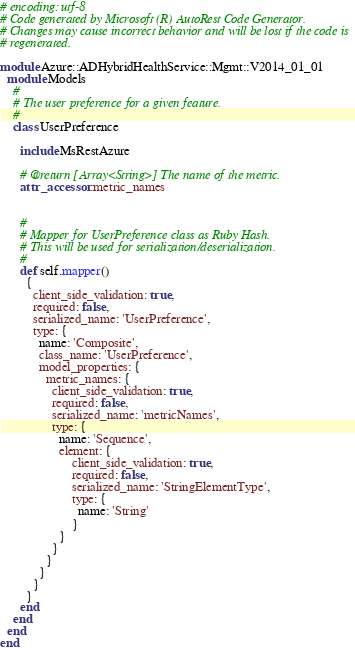Convert code to text. <code><loc_0><loc_0><loc_500><loc_500><_Ruby_># encoding: utf-8
# Code generated by Microsoft (R) AutoRest Code Generator.
# Changes may cause incorrect behavior and will be lost if the code is
# regenerated.

module Azure::ADHybridHealthService::Mgmt::V2014_01_01
  module Models
    #
    # The user preference for a given feature.
    #
    class UserPreference

      include MsRestAzure

      # @return [Array<String>] The name of the metric.
      attr_accessor :metric_names


      #
      # Mapper for UserPreference class as Ruby Hash.
      # This will be used for serialization/deserialization.
      #
      def self.mapper()
        {
          client_side_validation: true,
          required: false,
          serialized_name: 'UserPreference',
          type: {
            name: 'Composite',
            class_name: 'UserPreference',
            model_properties: {
              metric_names: {
                client_side_validation: true,
                required: false,
                serialized_name: 'metricNames',
                type: {
                  name: 'Sequence',
                  element: {
                      client_side_validation: true,
                      required: false,
                      serialized_name: 'StringElementType',
                      type: {
                        name: 'String'
                      }
                  }
                }
              }
            }
          }
        }
      end
    end
  end
end
</code> 